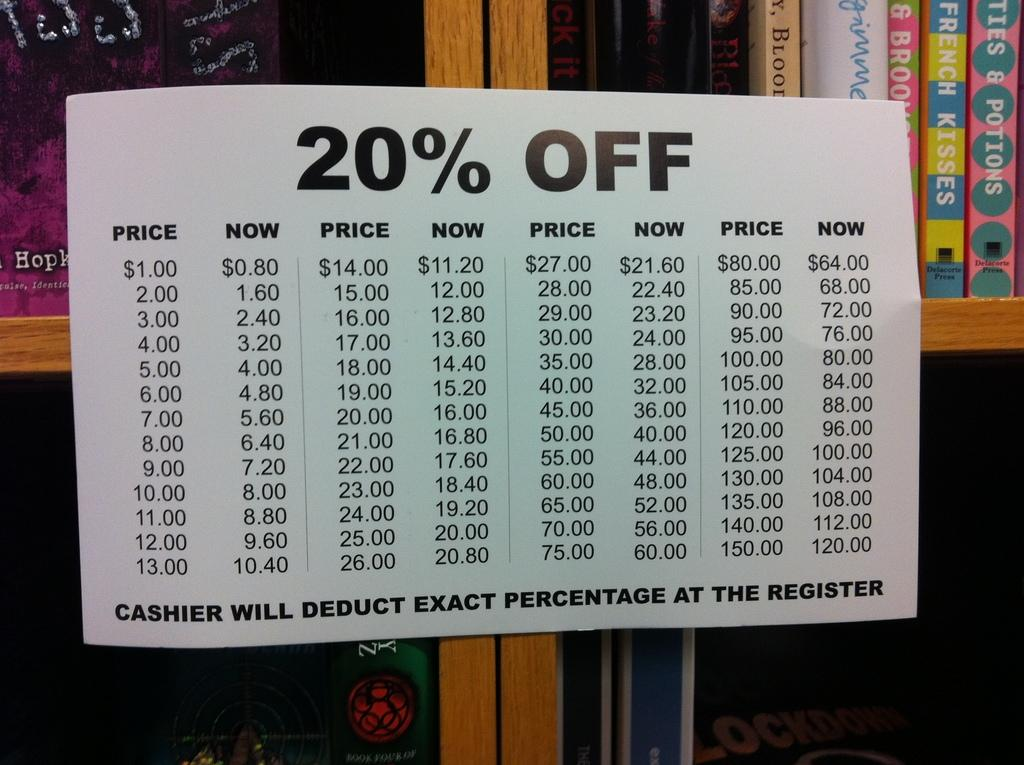Provide a one-sentence caption for the provided image. A sign taped to a bookshelf shows prices after a 20% deduction has been calculated. 